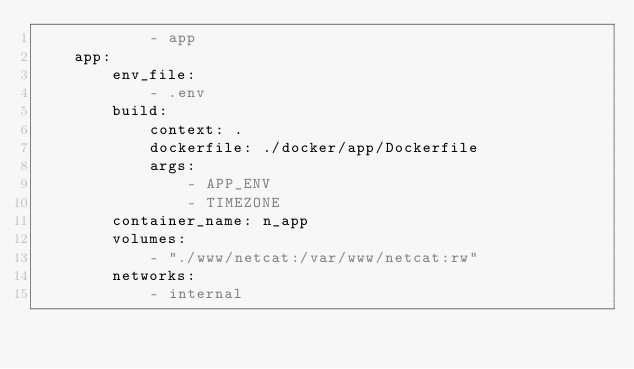Convert code to text. <code><loc_0><loc_0><loc_500><loc_500><_YAML_>            - app
    app:
        env_file:
            - .env
        build:
            context: .
            dockerfile: ./docker/app/Dockerfile
            args:
                - APP_ENV
                - TIMEZONE
        container_name: n_app
        volumes:
            - "./www/netcat:/var/www/netcat:rw"
        networks:
            - internal</code> 